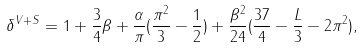<formula> <loc_0><loc_0><loc_500><loc_500>\delta ^ { V + S } = 1 + \frac { 3 } { 4 } \beta + \frac { \alpha } { \pi } ( \frac { \pi ^ { 2 } } { 3 } - \frac { 1 } { 2 } ) + \frac { \beta ^ { 2 } } { 2 4 } ( \frac { 3 7 } { 4 } - \frac { L } { 3 } - 2 \pi ^ { 2 } ) ,</formula> 